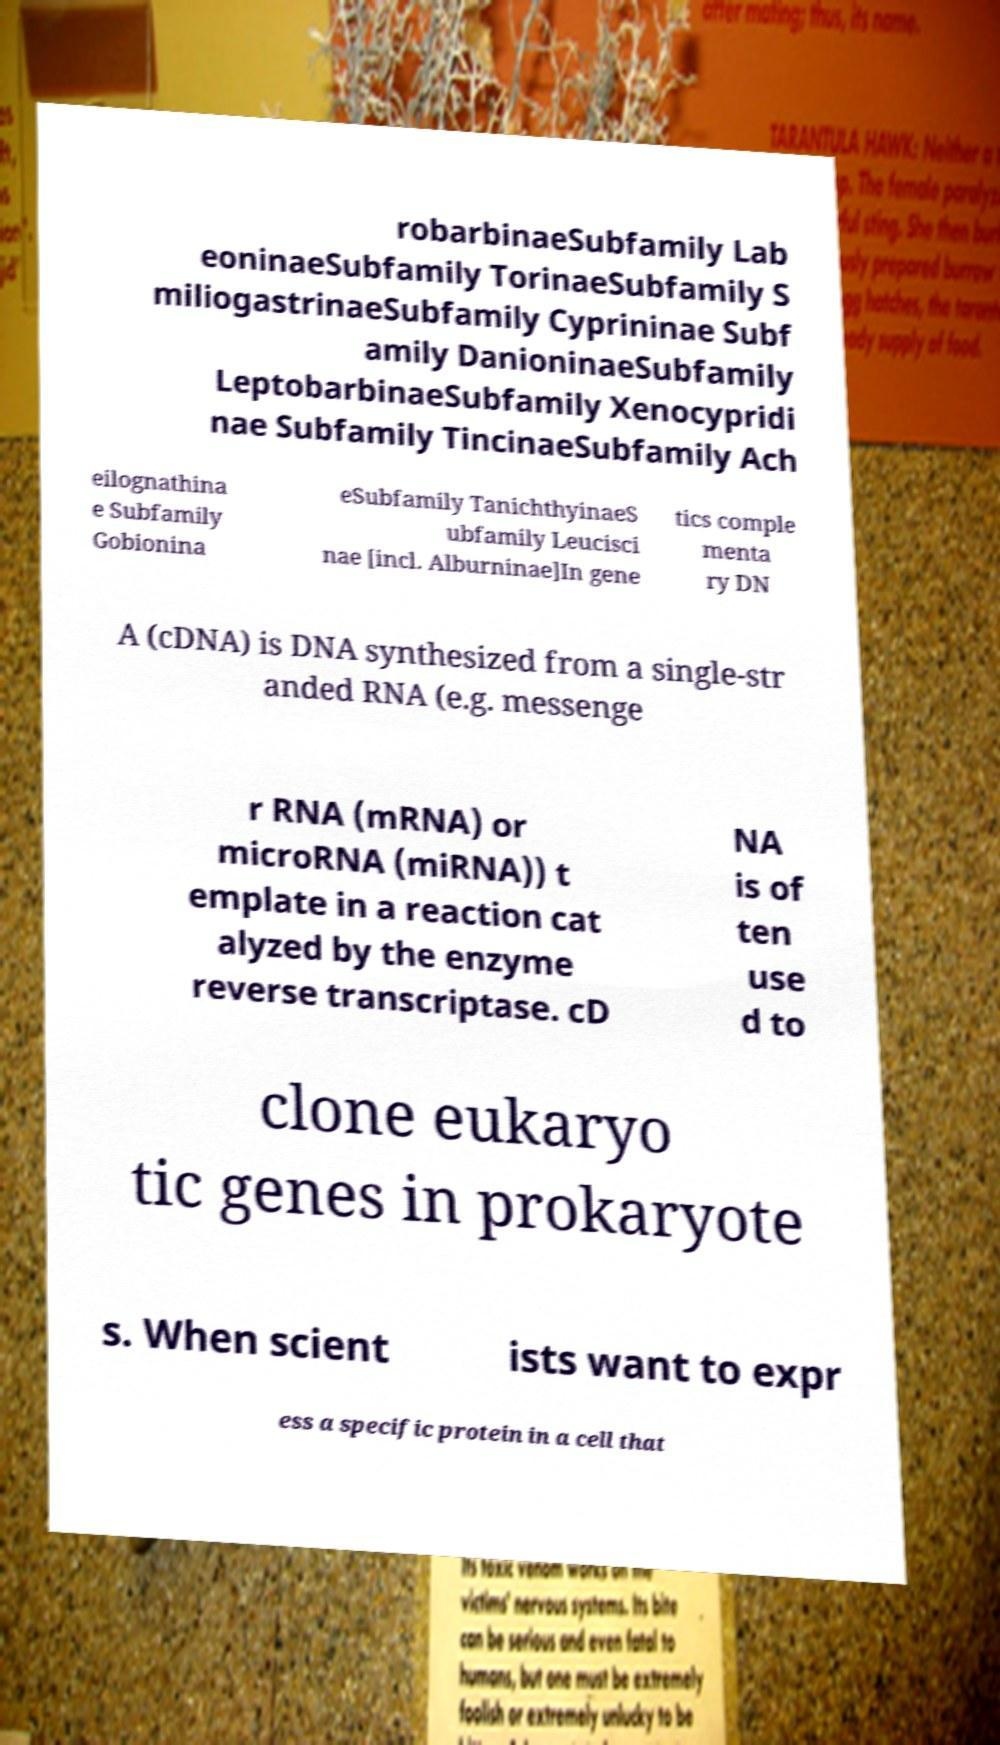There's text embedded in this image that I need extracted. Can you transcribe it verbatim? robarbinaeSubfamily Lab eoninaeSubfamily TorinaeSubfamily S miliogastrinaeSubfamily Cyprininae Subf amily DanioninaeSubfamily LeptobarbinaeSubfamily Xenocypridi nae Subfamily TincinaeSubfamily Ach eilognathina e Subfamily Gobionina eSubfamily TanichthyinaeS ubfamily Leucisci nae [incl. Alburninae]In gene tics comple menta ry DN A (cDNA) is DNA synthesized from a single-str anded RNA (e.g. messenge r RNA (mRNA) or microRNA (miRNA)) t emplate in a reaction cat alyzed by the enzyme reverse transcriptase. cD NA is of ten use d to clone eukaryo tic genes in prokaryote s. When scient ists want to expr ess a specific protein in a cell that 